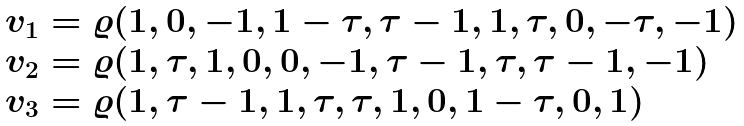Convert formula to latex. <formula><loc_0><loc_0><loc_500><loc_500>\begin{array} { l } v _ { 1 } = \varrho ( 1 , 0 , - 1 , 1 - \tau , \tau - 1 , 1 , \tau , 0 , - \tau , - 1 ) \\ v _ { 2 } = \varrho ( 1 , \tau , 1 , 0 , 0 , - 1 , \tau - 1 , \tau , \tau - 1 , - 1 ) \\ v _ { 3 } = \varrho ( 1 , \tau - 1 , 1 , \tau , \tau , 1 , 0 , 1 - \tau , 0 , 1 ) \end{array}</formula> 